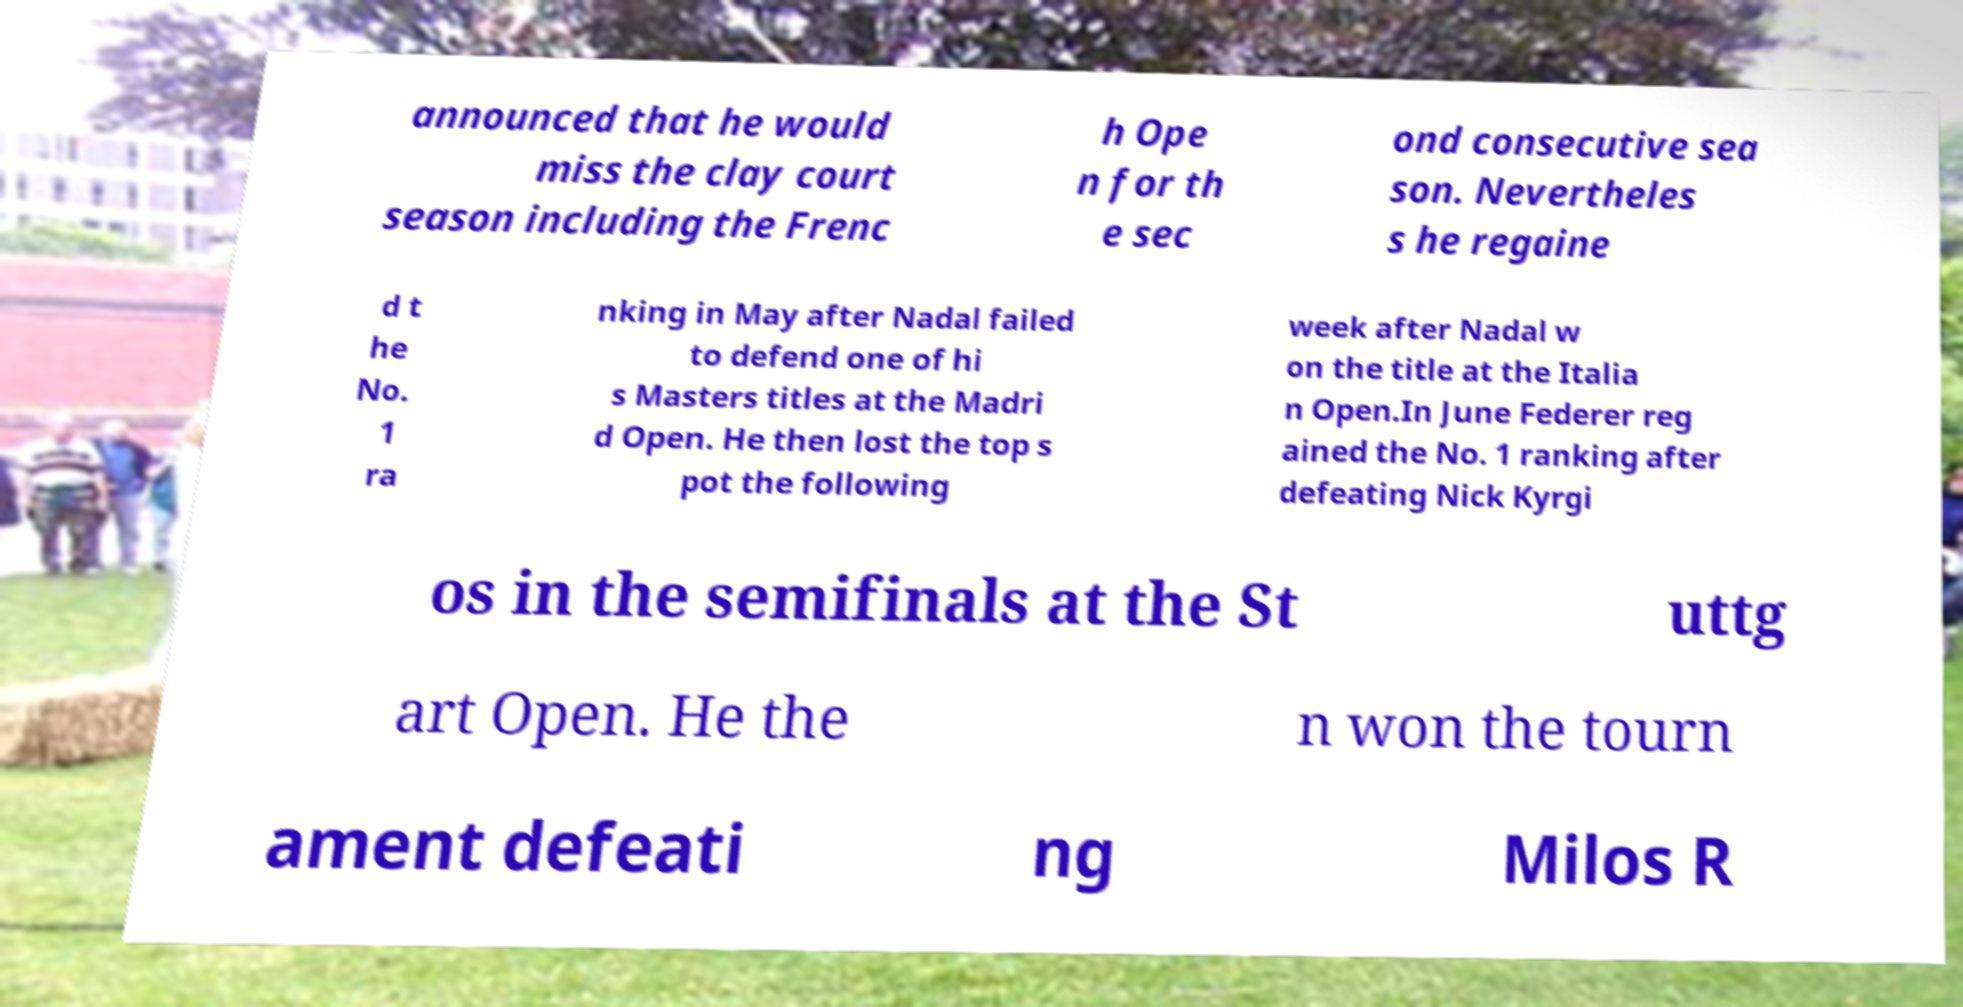Please identify and transcribe the text found in this image. announced that he would miss the clay court season including the Frenc h Ope n for th e sec ond consecutive sea son. Nevertheles s he regaine d t he No. 1 ra nking in May after Nadal failed to defend one of hi s Masters titles at the Madri d Open. He then lost the top s pot the following week after Nadal w on the title at the Italia n Open.In June Federer reg ained the No. 1 ranking after defeating Nick Kyrgi os in the semifinals at the St uttg art Open. He the n won the tourn ament defeati ng Milos R 